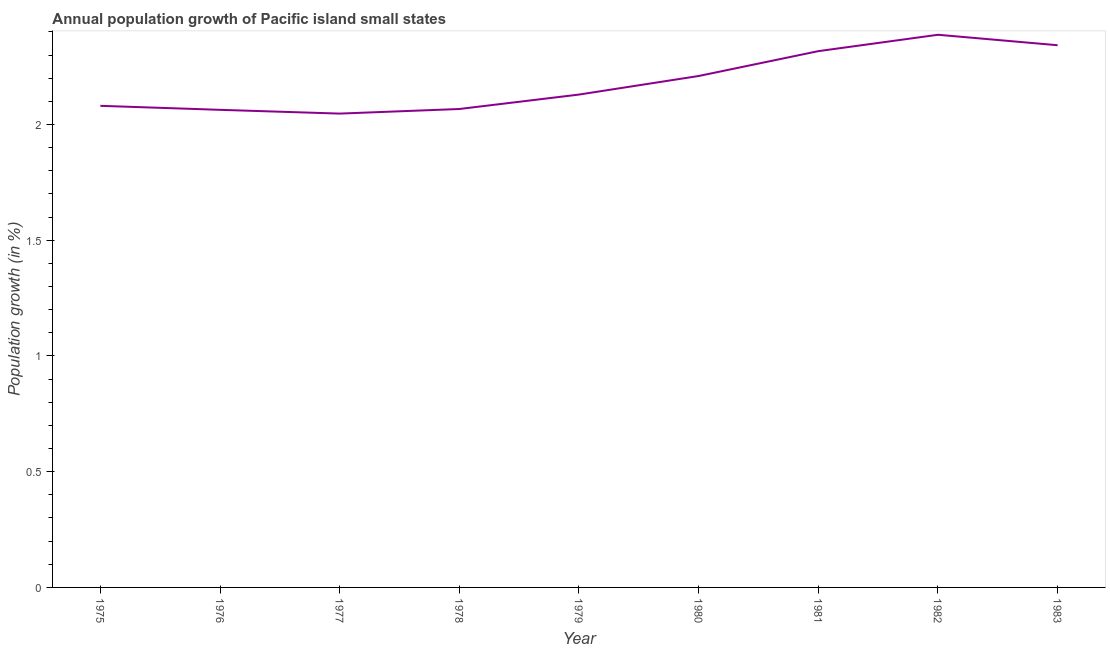What is the population growth in 1982?
Your response must be concise. 2.39. Across all years, what is the maximum population growth?
Provide a succinct answer. 2.39. Across all years, what is the minimum population growth?
Your answer should be compact. 2.05. In which year was the population growth maximum?
Make the answer very short. 1982. What is the sum of the population growth?
Your answer should be very brief. 19.65. What is the difference between the population growth in 1975 and 1976?
Keep it short and to the point. 0.02. What is the average population growth per year?
Ensure brevity in your answer.  2.18. What is the median population growth?
Provide a succinct answer. 2.13. In how many years, is the population growth greater than 0.1 %?
Your response must be concise. 9. Do a majority of the years between 1975 and 1981 (inclusive) have population growth greater than 2.3 %?
Your answer should be very brief. No. What is the ratio of the population growth in 1980 to that in 1983?
Your answer should be very brief. 0.94. Is the difference between the population growth in 1977 and 1983 greater than the difference between any two years?
Your response must be concise. No. What is the difference between the highest and the second highest population growth?
Keep it short and to the point. 0.05. Is the sum of the population growth in 1977 and 1978 greater than the maximum population growth across all years?
Provide a short and direct response. Yes. What is the difference between the highest and the lowest population growth?
Your answer should be very brief. 0.34. How many lines are there?
Ensure brevity in your answer.  1. How many years are there in the graph?
Offer a terse response. 9. What is the difference between two consecutive major ticks on the Y-axis?
Offer a very short reply. 0.5. What is the title of the graph?
Ensure brevity in your answer.  Annual population growth of Pacific island small states. What is the label or title of the Y-axis?
Make the answer very short. Population growth (in %). What is the Population growth (in %) of 1975?
Your answer should be compact. 2.08. What is the Population growth (in %) of 1976?
Your response must be concise. 2.06. What is the Population growth (in %) of 1977?
Provide a succinct answer. 2.05. What is the Population growth (in %) of 1978?
Keep it short and to the point. 2.07. What is the Population growth (in %) of 1979?
Provide a short and direct response. 2.13. What is the Population growth (in %) in 1980?
Your answer should be very brief. 2.21. What is the Population growth (in %) of 1981?
Offer a very short reply. 2.32. What is the Population growth (in %) in 1982?
Your response must be concise. 2.39. What is the Population growth (in %) in 1983?
Offer a terse response. 2.34. What is the difference between the Population growth (in %) in 1975 and 1976?
Provide a succinct answer. 0.02. What is the difference between the Population growth (in %) in 1975 and 1977?
Make the answer very short. 0.03. What is the difference between the Population growth (in %) in 1975 and 1978?
Offer a terse response. 0.01. What is the difference between the Population growth (in %) in 1975 and 1979?
Offer a very short reply. -0.05. What is the difference between the Population growth (in %) in 1975 and 1980?
Your answer should be compact. -0.13. What is the difference between the Population growth (in %) in 1975 and 1981?
Ensure brevity in your answer.  -0.24. What is the difference between the Population growth (in %) in 1975 and 1982?
Keep it short and to the point. -0.31. What is the difference between the Population growth (in %) in 1975 and 1983?
Your answer should be compact. -0.26. What is the difference between the Population growth (in %) in 1976 and 1977?
Offer a terse response. 0.02. What is the difference between the Population growth (in %) in 1976 and 1978?
Provide a short and direct response. -0. What is the difference between the Population growth (in %) in 1976 and 1979?
Your response must be concise. -0.07. What is the difference between the Population growth (in %) in 1976 and 1980?
Your response must be concise. -0.15. What is the difference between the Population growth (in %) in 1976 and 1981?
Ensure brevity in your answer.  -0.25. What is the difference between the Population growth (in %) in 1976 and 1982?
Keep it short and to the point. -0.32. What is the difference between the Population growth (in %) in 1976 and 1983?
Give a very brief answer. -0.28. What is the difference between the Population growth (in %) in 1977 and 1978?
Offer a terse response. -0.02. What is the difference between the Population growth (in %) in 1977 and 1979?
Give a very brief answer. -0.08. What is the difference between the Population growth (in %) in 1977 and 1980?
Ensure brevity in your answer.  -0.16. What is the difference between the Population growth (in %) in 1977 and 1981?
Your answer should be very brief. -0.27. What is the difference between the Population growth (in %) in 1977 and 1982?
Your answer should be compact. -0.34. What is the difference between the Population growth (in %) in 1977 and 1983?
Ensure brevity in your answer.  -0.3. What is the difference between the Population growth (in %) in 1978 and 1979?
Offer a terse response. -0.06. What is the difference between the Population growth (in %) in 1978 and 1980?
Make the answer very short. -0.14. What is the difference between the Population growth (in %) in 1978 and 1981?
Provide a short and direct response. -0.25. What is the difference between the Population growth (in %) in 1978 and 1982?
Provide a succinct answer. -0.32. What is the difference between the Population growth (in %) in 1978 and 1983?
Your answer should be very brief. -0.28. What is the difference between the Population growth (in %) in 1979 and 1980?
Provide a succinct answer. -0.08. What is the difference between the Population growth (in %) in 1979 and 1981?
Your answer should be compact. -0.19. What is the difference between the Population growth (in %) in 1979 and 1982?
Your answer should be compact. -0.26. What is the difference between the Population growth (in %) in 1979 and 1983?
Your answer should be very brief. -0.21. What is the difference between the Population growth (in %) in 1980 and 1981?
Your response must be concise. -0.11. What is the difference between the Population growth (in %) in 1980 and 1982?
Provide a short and direct response. -0.18. What is the difference between the Population growth (in %) in 1980 and 1983?
Your response must be concise. -0.13. What is the difference between the Population growth (in %) in 1981 and 1982?
Keep it short and to the point. -0.07. What is the difference between the Population growth (in %) in 1981 and 1983?
Your response must be concise. -0.03. What is the difference between the Population growth (in %) in 1982 and 1983?
Ensure brevity in your answer.  0.05. What is the ratio of the Population growth (in %) in 1975 to that in 1979?
Keep it short and to the point. 0.98. What is the ratio of the Population growth (in %) in 1975 to that in 1980?
Give a very brief answer. 0.94. What is the ratio of the Population growth (in %) in 1975 to that in 1981?
Ensure brevity in your answer.  0.9. What is the ratio of the Population growth (in %) in 1975 to that in 1982?
Provide a short and direct response. 0.87. What is the ratio of the Population growth (in %) in 1975 to that in 1983?
Provide a succinct answer. 0.89. What is the ratio of the Population growth (in %) in 1976 to that in 1978?
Your answer should be compact. 1. What is the ratio of the Population growth (in %) in 1976 to that in 1979?
Make the answer very short. 0.97. What is the ratio of the Population growth (in %) in 1976 to that in 1980?
Offer a very short reply. 0.93. What is the ratio of the Population growth (in %) in 1976 to that in 1981?
Your answer should be very brief. 0.89. What is the ratio of the Population growth (in %) in 1976 to that in 1982?
Provide a succinct answer. 0.86. What is the ratio of the Population growth (in %) in 1976 to that in 1983?
Your answer should be very brief. 0.88. What is the ratio of the Population growth (in %) in 1977 to that in 1978?
Ensure brevity in your answer.  0.99. What is the ratio of the Population growth (in %) in 1977 to that in 1979?
Your answer should be very brief. 0.96. What is the ratio of the Population growth (in %) in 1977 to that in 1980?
Your answer should be very brief. 0.93. What is the ratio of the Population growth (in %) in 1977 to that in 1981?
Your response must be concise. 0.88. What is the ratio of the Population growth (in %) in 1977 to that in 1982?
Offer a very short reply. 0.86. What is the ratio of the Population growth (in %) in 1977 to that in 1983?
Provide a succinct answer. 0.87. What is the ratio of the Population growth (in %) in 1978 to that in 1980?
Give a very brief answer. 0.94. What is the ratio of the Population growth (in %) in 1978 to that in 1981?
Your answer should be compact. 0.89. What is the ratio of the Population growth (in %) in 1978 to that in 1982?
Ensure brevity in your answer.  0.87. What is the ratio of the Population growth (in %) in 1978 to that in 1983?
Your response must be concise. 0.88. What is the ratio of the Population growth (in %) in 1979 to that in 1980?
Provide a succinct answer. 0.96. What is the ratio of the Population growth (in %) in 1979 to that in 1981?
Ensure brevity in your answer.  0.92. What is the ratio of the Population growth (in %) in 1979 to that in 1982?
Give a very brief answer. 0.89. What is the ratio of the Population growth (in %) in 1979 to that in 1983?
Give a very brief answer. 0.91. What is the ratio of the Population growth (in %) in 1980 to that in 1981?
Provide a succinct answer. 0.95. What is the ratio of the Population growth (in %) in 1980 to that in 1982?
Your answer should be very brief. 0.93. What is the ratio of the Population growth (in %) in 1980 to that in 1983?
Ensure brevity in your answer.  0.94. 